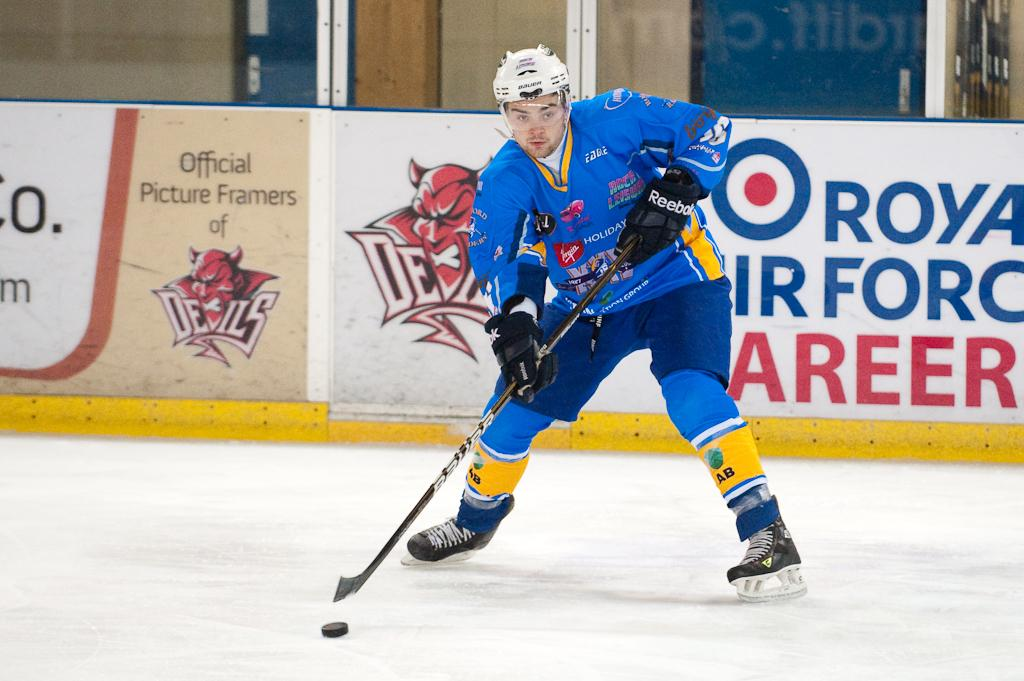<image>
Present a compact description of the photo's key features. A player stands in front of a board that says official picture framers of the team. 